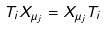Convert formula to latex. <formula><loc_0><loc_0><loc_500><loc_500>T _ { i } X _ { \mu _ { j } } = X _ { \mu _ { j } } T _ { i }</formula> 